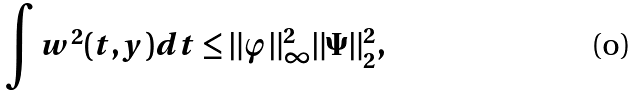<formula> <loc_0><loc_0><loc_500><loc_500>\int w ^ { 2 } ( t , y ) d t \leq \| \varphi \| _ { \infty } ^ { 2 } \| \Psi \| _ { 2 } ^ { 2 } ,</formula> 